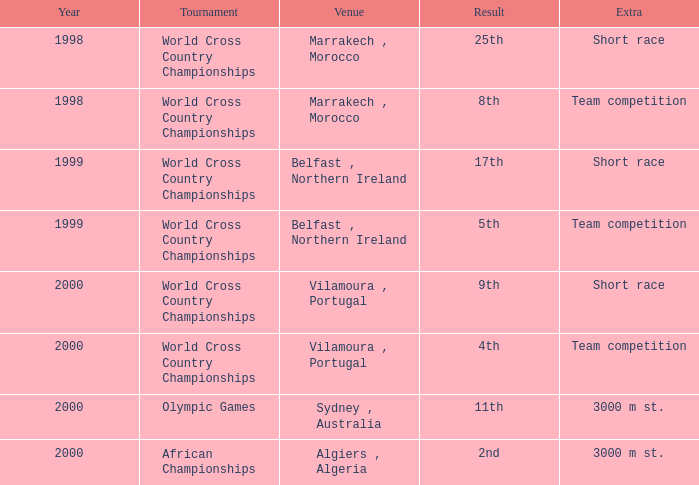Would you mind parsing the complete table? {'header': ['Year', 'Tournament', 'Venue', 'Result', 'Extra'], 'rows': [['1998', 'World Cross Country Championships', 'Marrakech , Morocco', '25th', 'Short race'], ['1998', 'World Cross Country Championships', 'Marrakech , Morocco', '8th', 'Team competition'], ['1999', 'World Cross Country Championships', 'Belfast , Northern Ireland', '17th', 'Short race'], ['1999', 'World Cross Country Championships', 'Belfast , Northern Ireland', '5th', 'Team competition'], ['2000', 'World Cross Country Championships', 'Vilamoura , Portugal', '9th', 'Short race'], ['2000', 'World Cross Country Championships', 'Vilamoura , Portugal', '4th', 'Team competition'], ['2000', 'Olympic Games', 'Sydney , Australia', '11th', '3000 m st.'], ['2000', 'African Championships', 'Algiers , Algeria', '2nd', '3000 m st.']]} Can you provide information on extra competitions in the olympic games tournament? 3000 m st. 